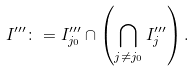Convert formula to latex. <formula><loc_0><loc_0><loc_500><loc_500>I ^ { \prime \prime \prime } \colon = I ^ { \prime \prime \prime } _ { j _ { 0 } } \cap \left ( \bigcap _ { j \neq j _ { 0 } } I ^ { \prime \prime \prime } _ { j } \right ) .</formula> 